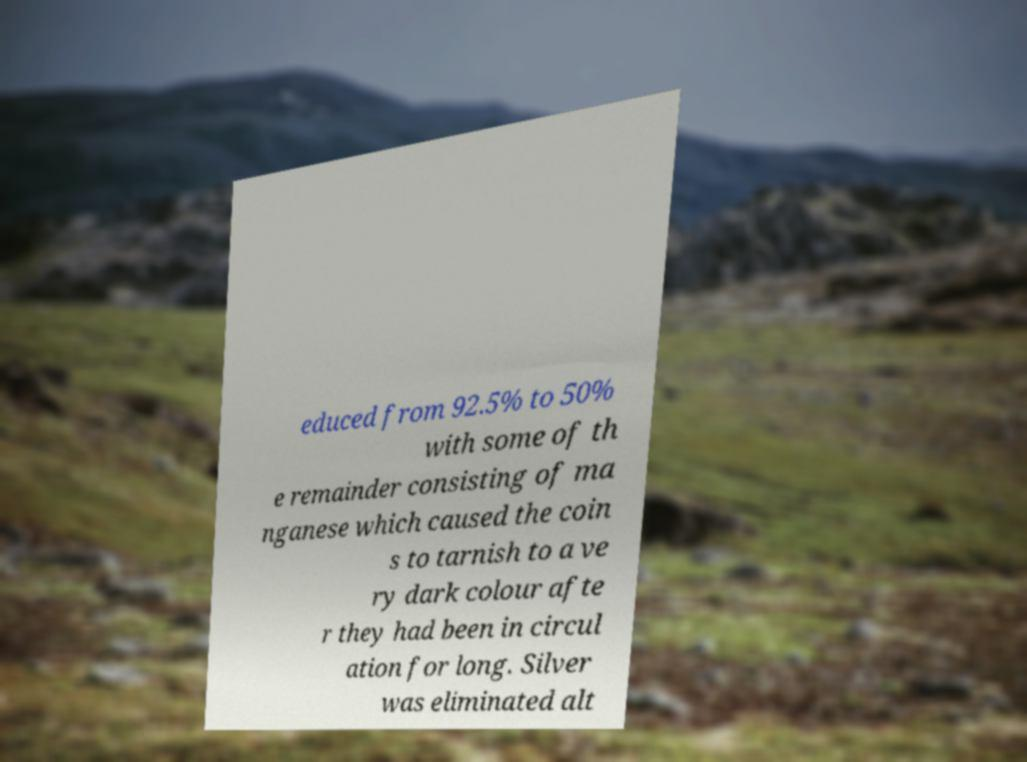There's text embedded in this image that I need extracted. Can you transcribe it verbatim? educed from 92.5% to 50% with some of th e remainder consisting of ma nganese which caused the coin s to tarnish to a ve ry dark colour afte r they had been in circul ation for long. Silver was eliminated alt 